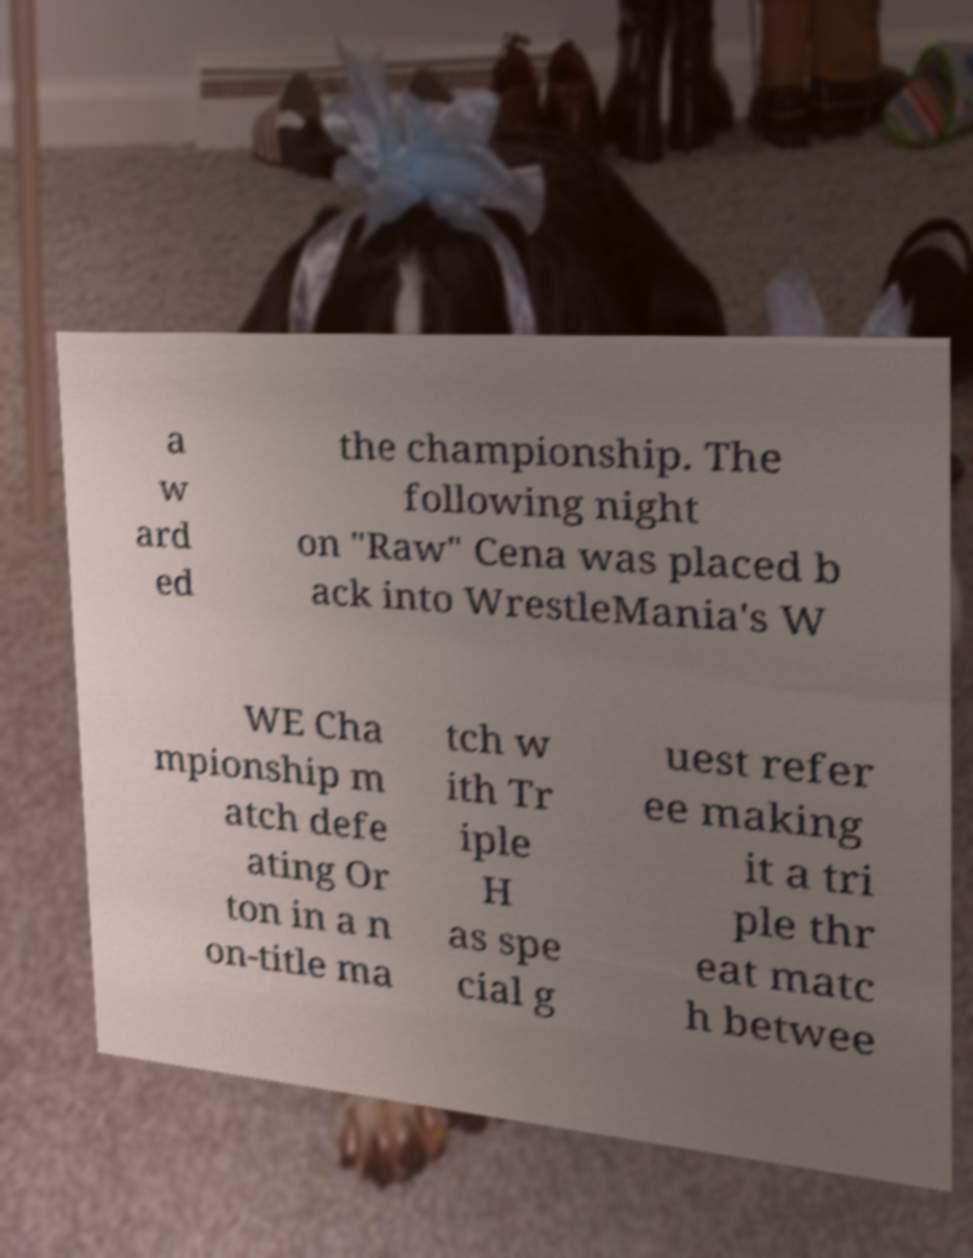There's text embedded in this image that I need extracted. Can you transcribe it verbatim? a w ard ed the championship. The following night on "Raw" Cena was placed b ack into WrestleMania's W WE Cha mpionship m atch defe ating Or ton in a n on-title ma tch w ith Tr iple H as spe cial g uest refer ee making it a tri ple thr eat matc h betwee 